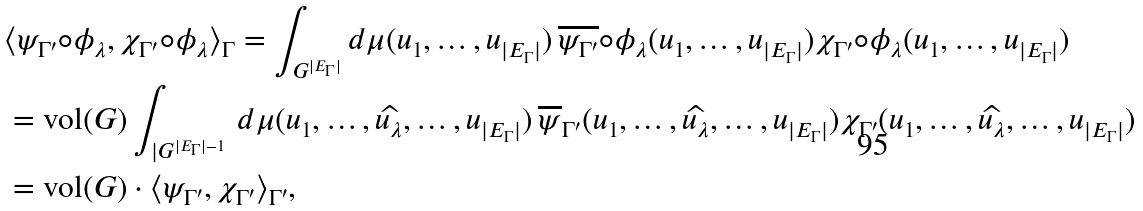<formula> <loc_0><loc_0><loc_500><loc_500>& \langle \psi _ { \Gamma ^ { \prime } } \circ \phi _ { \lambda } , \chi _ { \Gamma ^ { \prime } } \circ \phi _ { \lambda } \rangle _ { \Gamma } = \int _ { G ^ { | E _ { \Gamma } | } } d \mu ( u _ { 1 } , \dots , u _ { | E _ { \Gamma } | } ) \, \overline { \psi _ { \Gamma ^ { \prime } } } \circ \phi _ { \lambda } ( u _ { 1 } , \dots , u _ { | E _ { \Gamma } | } ) \chi _ { \Gamma ^ { \prime } } \circ \phi _ { \lambda } ( u _ { 1 } , \dots , u _ { | E _ { \Gamma } | } ) \\ & = \text {vol} ( G ) \int _ { | G ^ { | E _ { \Gamma } | - 1 } } \, d \mu ( u _ { 1 } , \dots , \widehat { u _ { \lambda } } , \dots , u _ { | E _ { \Gamma } | } ) \, \overline { \psi } _ { \Gamma ^ { \prime } } ( u _ { 1 } , \dots , \widehat { u _ { \lambda } } , \dots , u _ { | E _ { \Gamma } | } ) \chi _ { \Gamma ^ { \prime } } ( u _ { 1 } , \dots , \widehat { u _ { \lambda } } , \dots , u _ { | E _ { \Gamma } | } ) \\ & = \text {vol} ( G ) \cdot \langle \psi _ { \Gamma ^ { \prime } } , \chi _ { \Gamma ^ { \prime } } \rangle _ { \Gamma ^ { \prime } } ,</formula> 